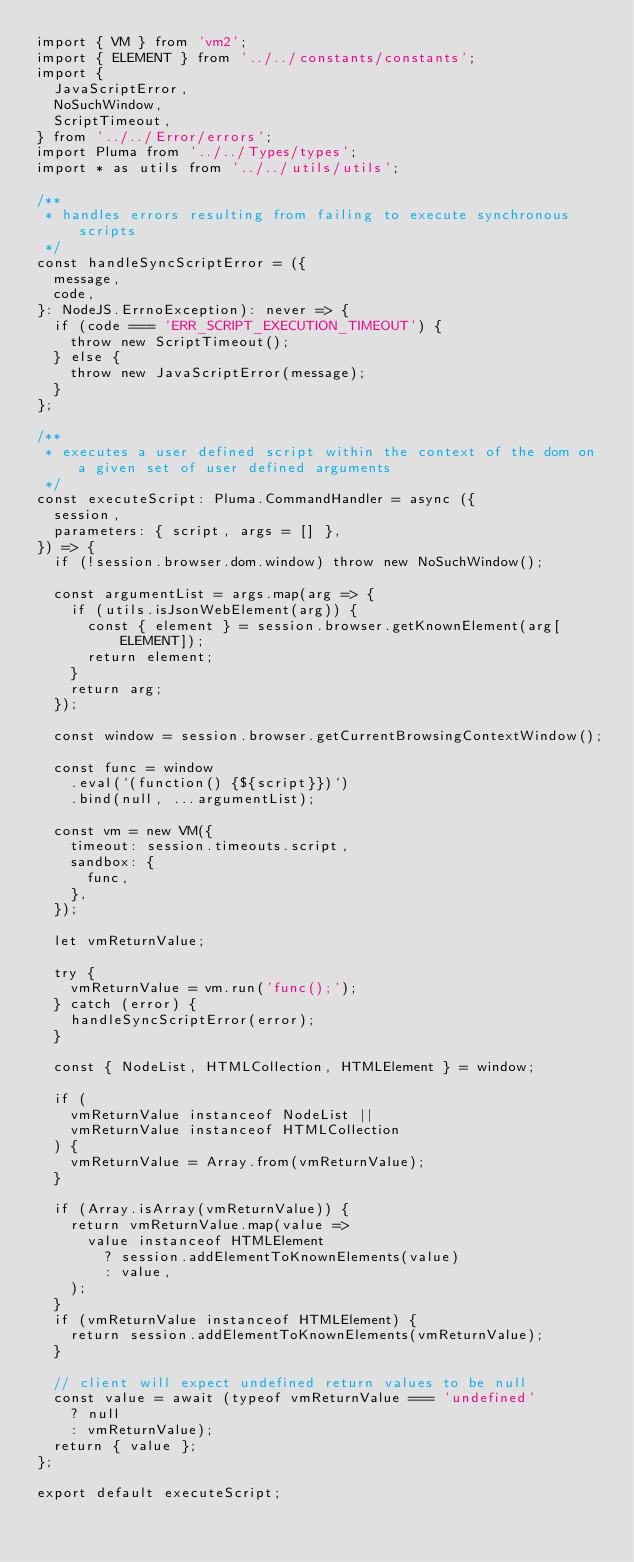Convert code to text. <code><loc_0><loc_0><loc_500><loc_500><_TypeScript_>import { VM } from 'vm2';
import { ELEMENT } from '../../constants/constants';
import {
  JavaScriptError,
  NoSuchWindow,
  ScriptTimeout,
} from '../../Error/errors';
import Pluma from '../../Types/types';
import * as utils from '../../utils/utils';

/**
 * handles errors resulting from failing to execute synchronous scripts
 */
const handleSyncScriptError = ({
  message,
  code,
}: NodeJS.ErrnoException): never => {
  if (code === 'ERR_SCRIPT_EXECUTION_TIMEOUT') {
    throw new ScriptTimeout();
  } else {
    throw new JavaScriptError(message);
  }
};

/**
 * executes a user defined script within the context of the dom on a given set of user defined arguments
 */
const executeScript: Pluma.CommandHandler = async ({
  session,
  parameters: { script, args = [] },
}) => {
  if (!session.browser.dom.window) throw new NoSuchWindow();

  const argumentList = args.map(arg => {
    if (utils.isJsonWebElement(arg)) {
      const { element } = session.browser.getKnownElement(arg[ELEMENT]);
      return element;
    }
    return arg;
  });

  const window = session.browser.getCurrentBrowsingContextWindow();

  const func = window
    .eval(`(function() {${script}})`)
    .bind(null, ...argumentList);

  const vm = new VM({
    timeout: session.timeouts.script,
    sandbox: {
      func,
    },
  });

  let vmReturnValue;

  try {
    vmReturnValue = vm.run('func();');
  } catch (error) {
    handleSyncScriptError(error);
  }

  const { NodeList, HTMLCollection, HTMLElement } = window;

  if (
    vmReturnValue instanceof NodeList ||
    vmReturnValue instanceof HTMLCollection
  ) {
    vmReturnValue = Array.from(vmReturnValue);
  }

  if (Array.isArray(vmReturnValue)) {
    return vmReturnValue.map(value =>
      value instanceof HTMLElement
        ? session.addElementToKnownElements(value)
        : value,
    );
  }
  if (vmReturnValue instanceof HTMLElement) {
    return session.addElementToKnownElements(vmReturnValue);
  }

  // client will expect undefined return values to be null
  const value = await (typeof vmReturnValue === 'undefined'
    ? null
    : vmReturnValue);
  return { value };
};

export default executeScript;
</code> 